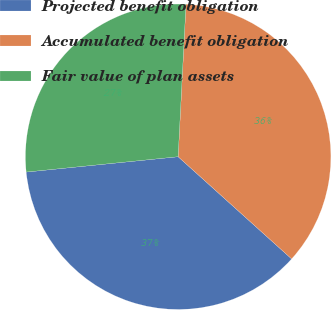<chart> <loc_0><loc_0><loc_500><loc_500><pie_chart><fcel>Projected benefit obligation<fcel>Accumulated benefit obligation<fcel>Fair value of plan assets<nl><fcel>36.73%<fcel>35.85%<fcel>27.42%<nl></chart> 